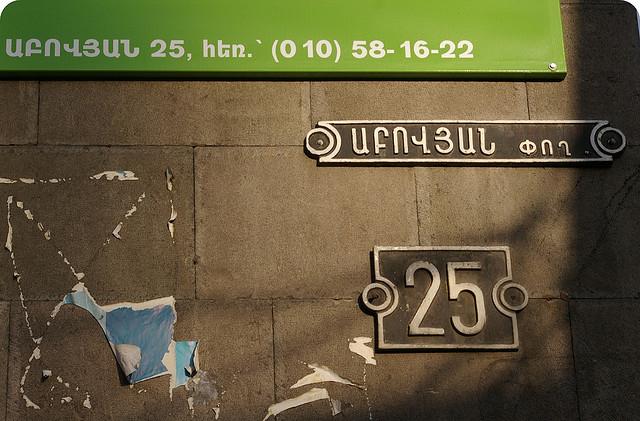What is this wall made of?
Give a very brief answer. Concrete. What is the number shown that is written in English?
Write a very short answer. 25. What material is the blue portion made of?
Keep it brief. Paper. What number is the biggest in the picture?
Answer briefly. 25. The number is 6?
Keep it brief. No. What is the figure number?
Short answer required. 25. 